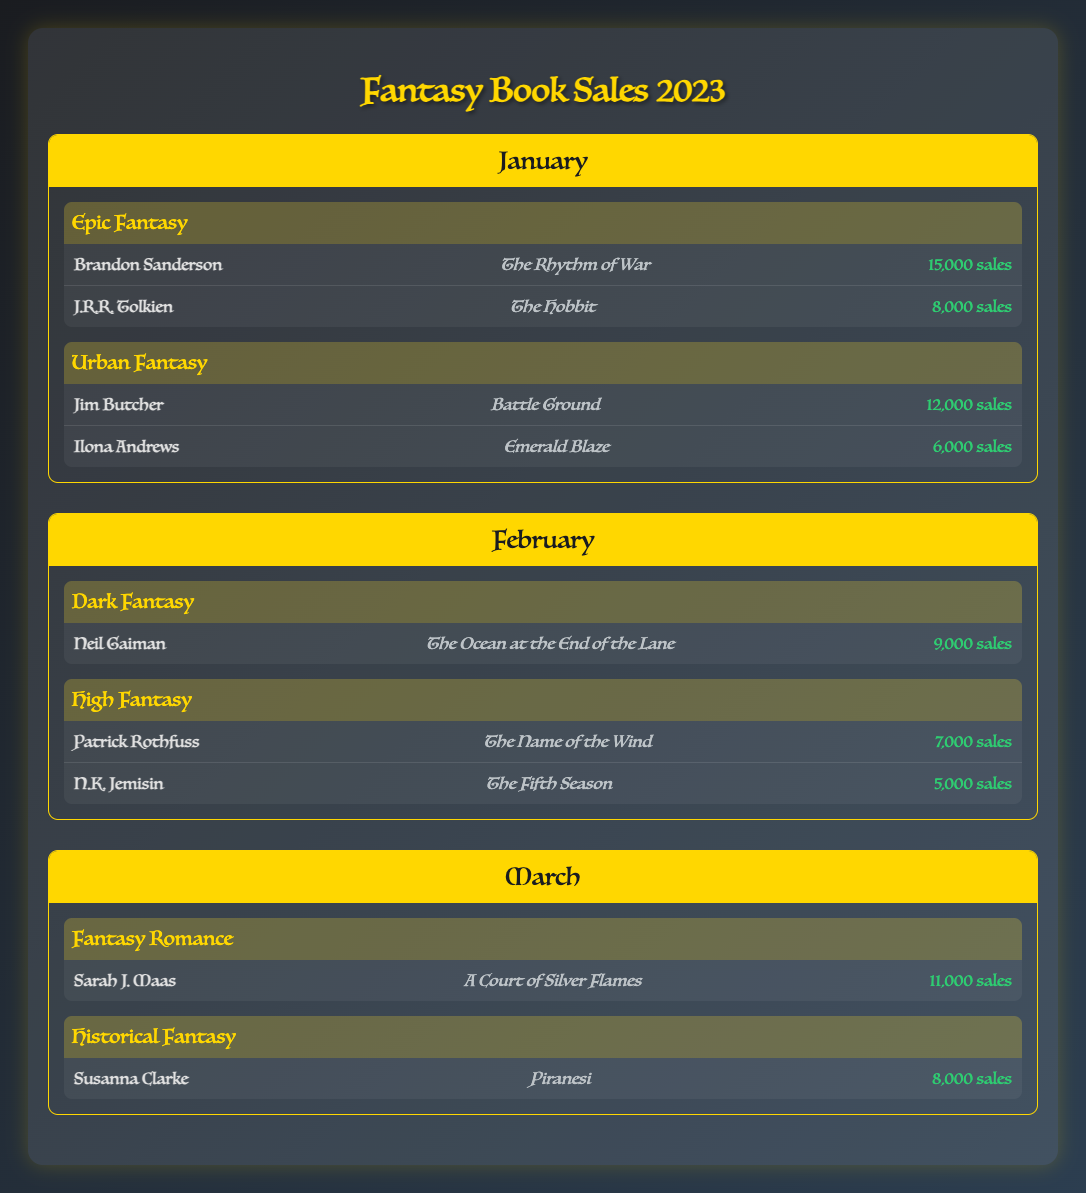What were the total sales for Epic Fantasy in January? The table shows that Epic Fantasy had two authors: Brandon Sanderson with 15,000 sales and J.R.R. Tolkien with 8,000 sales. To find the total sales, we add these two values together: 15,000 + 8,000 = 23,000.
Answer: 23,000 Which author had the highest sales in February? In February, the authors in the table are Neil Gaiman with 9,000 sales, Patrick Rothfuss with 7,000 sales, and N.K. Jemisin with 5,000 sales. Comparing these, Neil Gaiman has the highest sales of 9,000.
Answer: Neil Gaiman Did Sarah J. Maas have a book that sold more than 10,000 copies in March? Sarah J. Maas had a book titled "A Court of Silver Flames" with 11,000 sales in March. Since 11,000 is indeed more than 10,000, the answer is yes.
Answer: Yes What is the difference in sales between Jim Butcher and Ilona Andrews in January? In January, Jim Butcher sold 12,000 copies, while Ilona Andrews sold 6,000 copies. To find the difference, we subtract Ilona Andrews' sales from Jim Butcher's: 12,000 - 6,000 = 6,000.
Answer: 6,000 What genres were represented in the book sales for March? In March, there are two genres listed: Fantasy Romance and Historical Fantasy. This is retrieved directly from the genre categories presented in the March section of the table.
Answer: Fantasy Romance and Historical Fantasy 